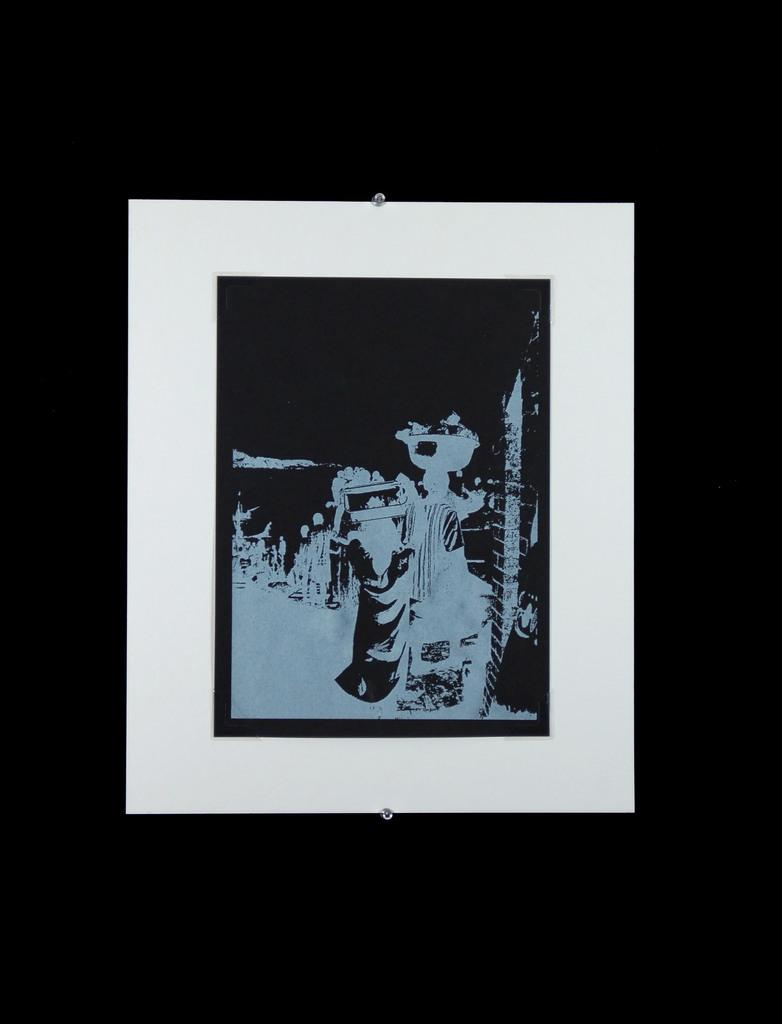What is the person in the image doing? The person is sitting on a chair and reading a book. Are there any other people in the image? No, the image only shows one person. What is the person holding in the image? The person is holding a book. What type of zephyr is the person riding in the image? There is no zephyr present in the image, as the person is sitting on a chair and reading a book. --- Facts: 1. There is a group of people standing near a car. 2. The car is red. 3. The people are smiling. Conversation: How many people are in the image? There is a group of people in the image. What are the people doing in the image? The people are standing near a car. What color is the car in the image? The car is red. What is the mood of the people in the image? The people are smiling, which suggests a positive mood. Reasoning: Let's think step by step in order to produce the conversation. We start by identifying the main subjects in the image, which are the group of people and the red car. Then, we expand the conversation to include other details about the people and their activity. Each question is designed to elicit a specific detail about the image that is known from the provided facts. Absurd Question/Answer: What type of blade is the person holding in the image? There is no person holding a blade in the image, as the people are standing near a car and smiling. --- Facts: 1. There is a person holding a camera and taking a picture. 2. The person is standing near a tree. 3. The camera is black. Conversation: What is the person in the image doing? The person is holding a camera and taking a picture. Where is the person standing in the image? The person is standing near a tree. What color is the camera in the image? The camera is black. Reasoning: Let's think step by step in order to produce the conversation. We start by identifying the main subject in the image, which is the person holding a camera and taking a picture. Then, we expand the conversation to include other details about the person and their activity. Each question is designed to elicit a specific detail about the image that is known from the provided facts. Absurd Question/Answer: What type of jail is visible in the image? There is no jail present in the image, as the person is holding a camera and taking a picture while standing near a tree. --- Facts: 1. There is a person standing near a tree. 2. The person is holding a book. 3. The book is blue. Conversation: What is the person in the image doing? The person is standing near a 